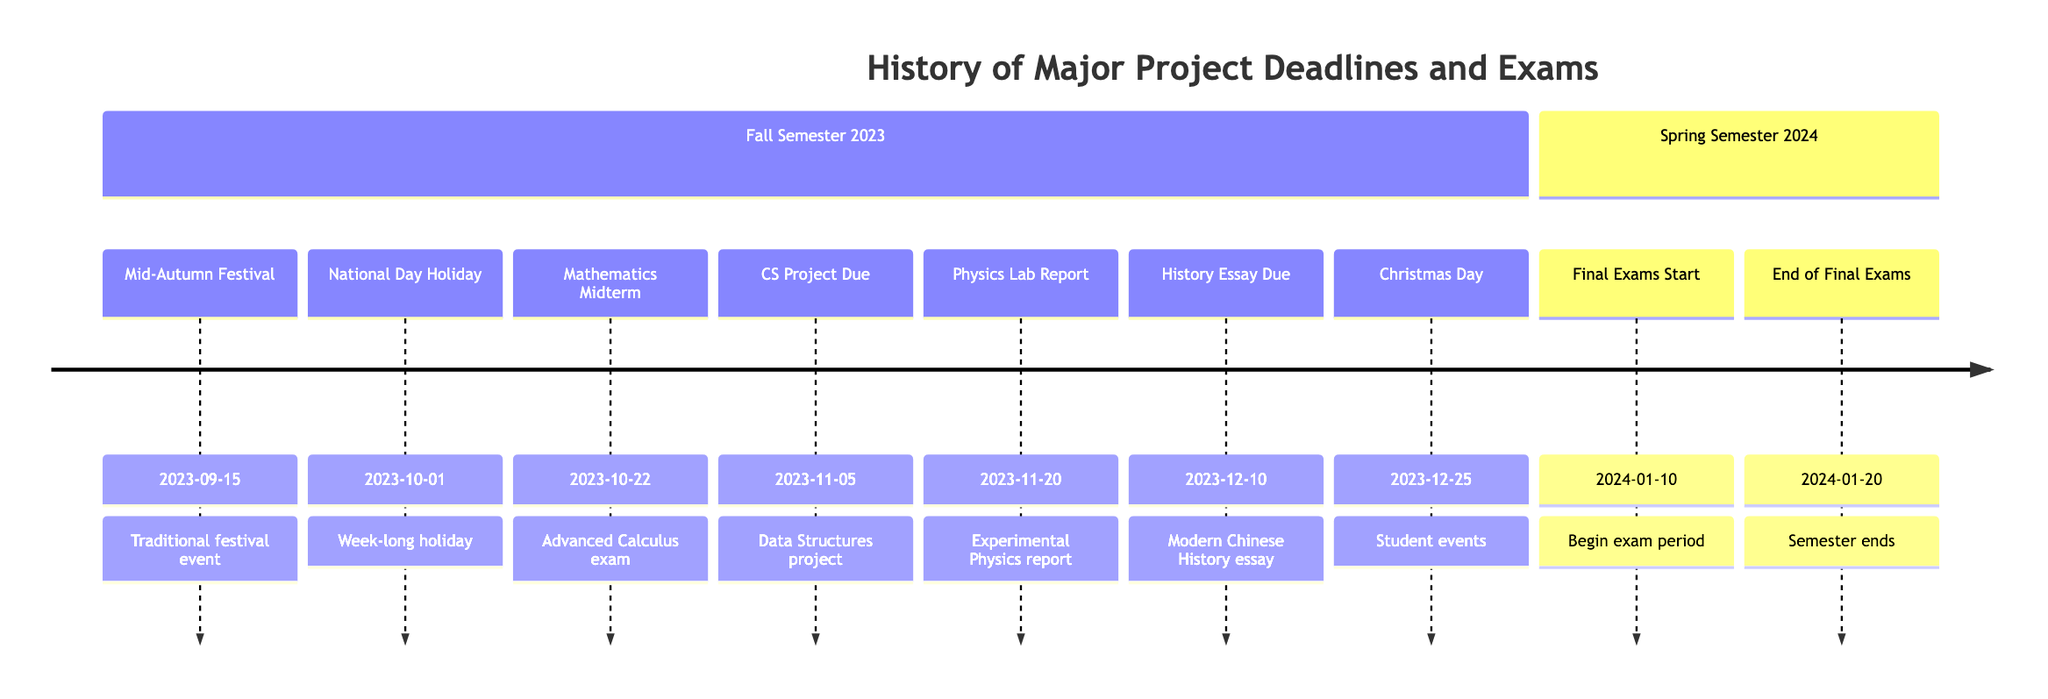What event occurs on September 15, 2023? The diagram indicates that on September 15, 2023, there is a Mid-Autumn Festival Celebration organized by the Student Union at Beihang University.
Answer: Mid-Autumn Festival Celebration What is the date of the Mathematics Midterm Exam? The Mathematics Midterm Exam is listed in the timeline and is scheduled for October 22, 2023.
Answer: October 22, 2023 How many events are listed in the Fall Semester of 2023? By counting the events in the Fall Semester section of the timeline, there are a total of 7 events.
Answer: 7 When is the history essay due? The timeline shows that the History Essay is due on December 10, 2023, according to the listed events for that semester.
Answer: December 10, 2023 What event follows the Computer Science Project Submission? After the Computer Science Project Submission on November 5, 2023, the next event on the timeline is the Physics Lab Report due on November 20, 2023.
Answer: Physics Lab Report Due What is the length of the National Day Holiday? According to the timeline, the National Day Holiday is described as a week-long holiday, lasting for 7 days with no classes held during this period.
Answer: Week-long What is the final deadline before the final exams start in January 2024? The timeline lists the final deadline before the final exams start as the History Essay due on December 10, 2023.
Answer: History Essay Due What is the interval between the end of the final exams and Christmas Day? The timeline indicates that the final exams end on January 20, 2024, and Christmas Day is celebrated on December 25, 2023, which means there is an interval of 26 days.
Answer: 26 days How many days are there between the Mathematics Midterm Exam and the CS Project Submission? The Mathematics Midterm Exam is on October 22, 2023, and the CS Project Submission deadline is on November 5, 2023. The interval between these two dates is 14 days.
Answer: 14 days 